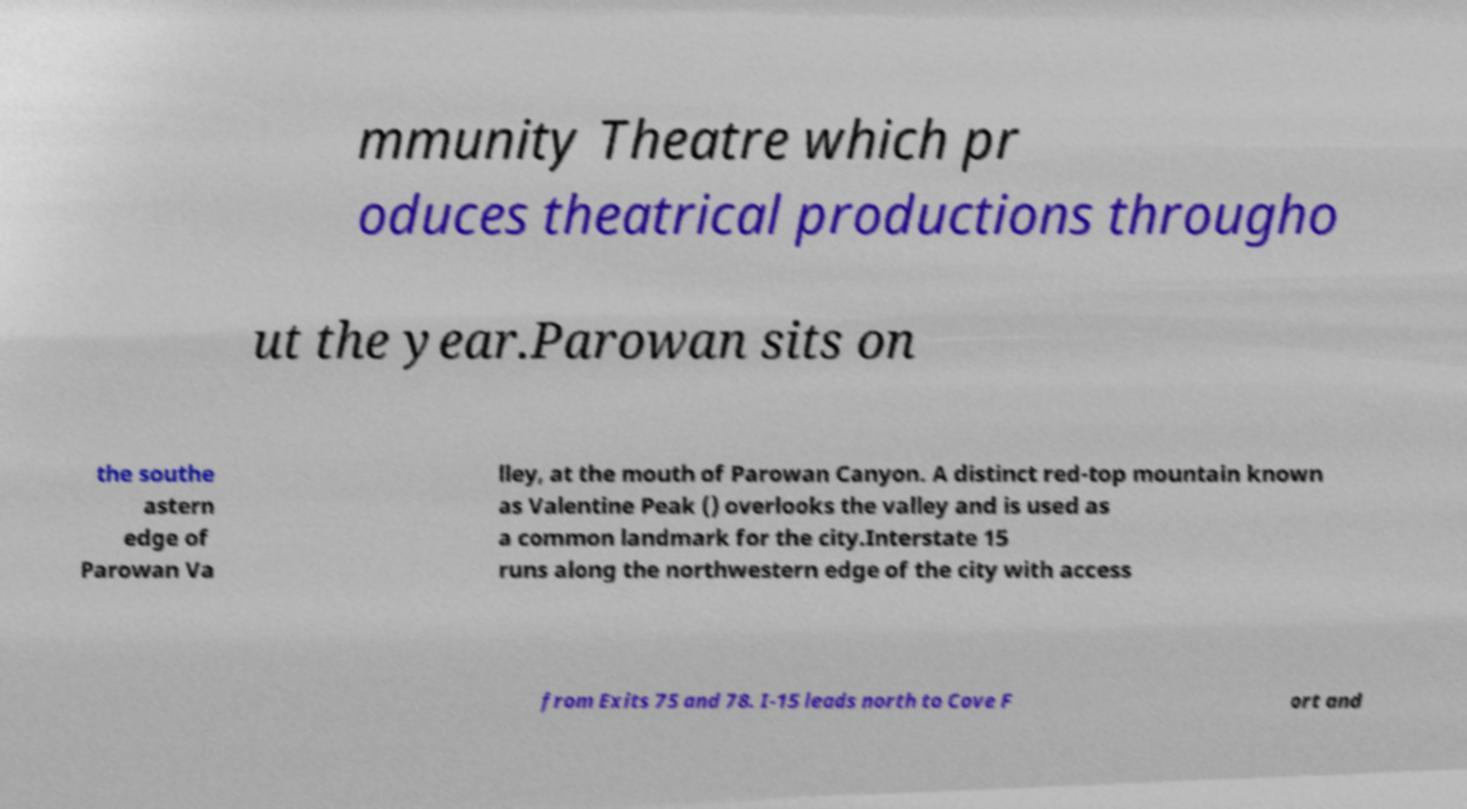What messages or text are displayed in this image? I need them in a readable, typed format. mmunity Theatre which pr oduces theatrical productions througho ut the year.Parowan sits on the southe astern edge of Parowan Va lley, at the mouth of Parowan Canyon. A distinct red-top mountain known as Valentine Peak () overlooks the valley and is used as a common landmark for the city.Interstate 15 runs along the northwestern edge of the city with access from Exits 75 and 78. I-15 leads north to Cove F ort and 